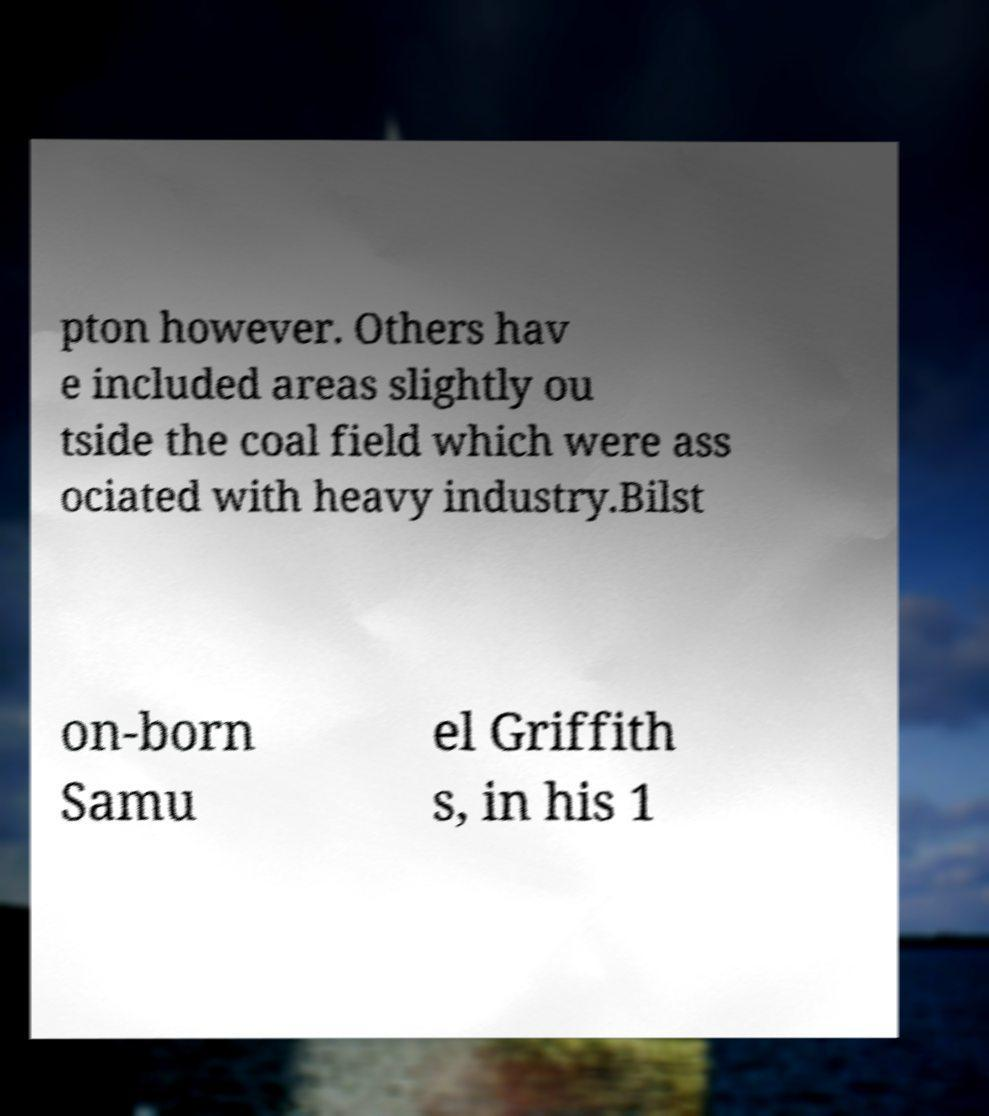Could you extract and type out the text from this image? pton however. Others hav e included areas slightly ou tside the coal field which were ass ociated with heavy industry.Bilst on-born Samu el Griffith s, in his 1 